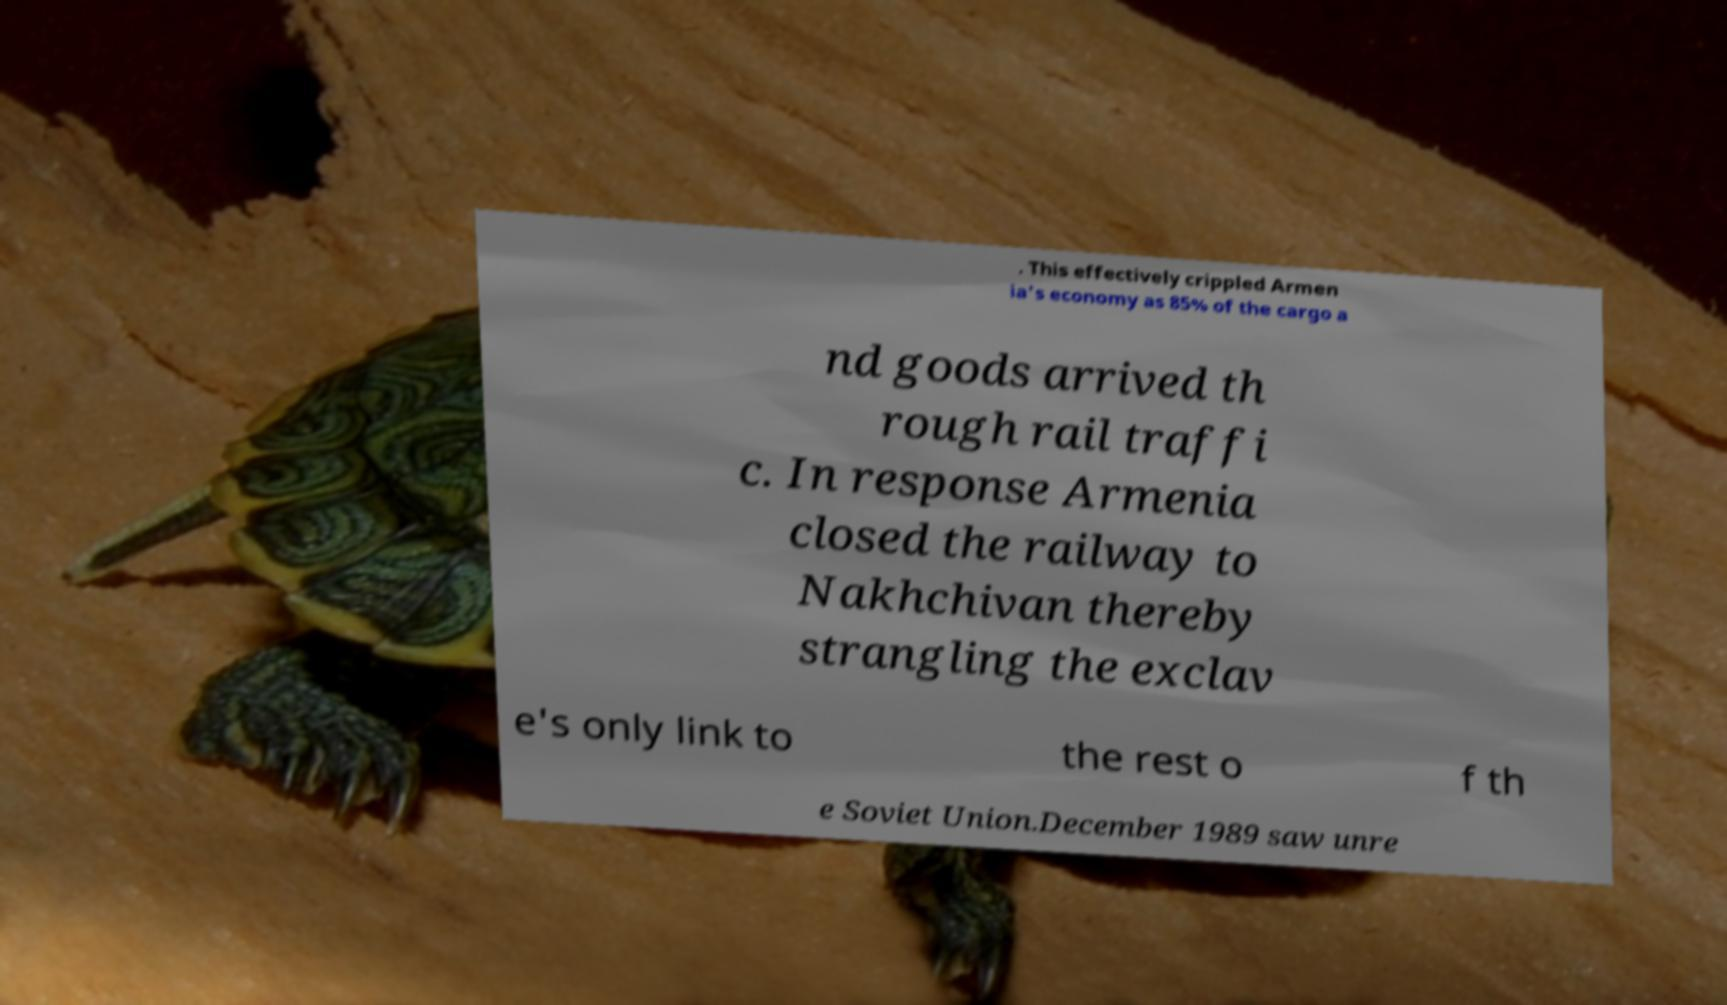Can you accurately transcribe the text from the provided image for me? . This effectively crippled Armen ia's economy as 85% of the cargo a nd goods arrived th rough rail traffi c. In response Armenia closed the railway to Nakhchivan thereby strangling the exclav e's only link to the rest o f th e Soviet Union.December 1989 saw unre 